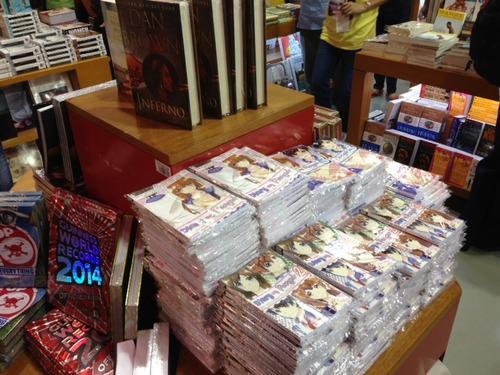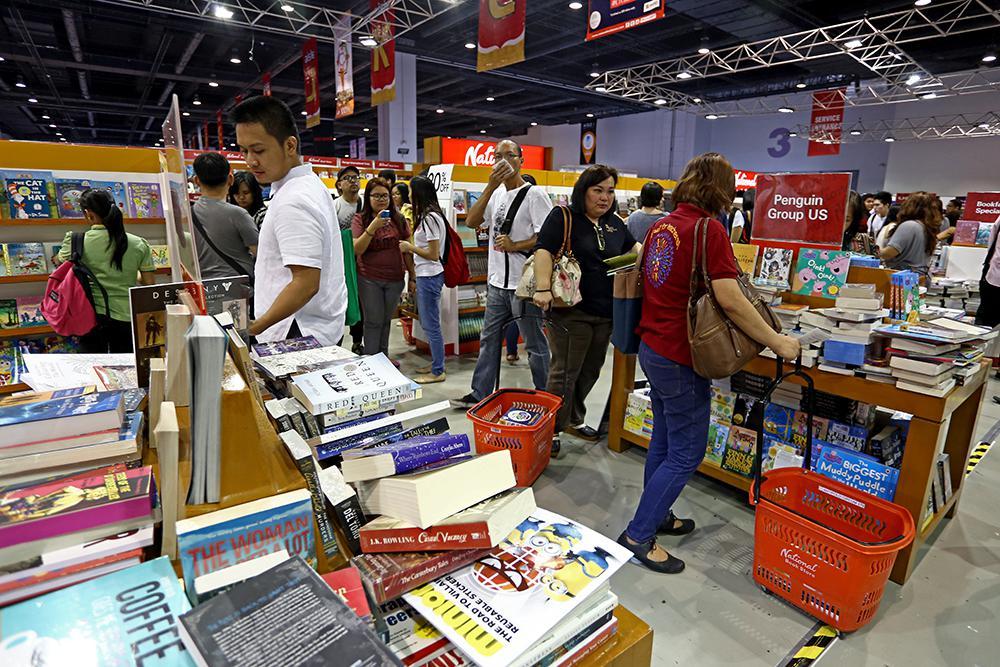The first image is the image on the left, the second image is the image on the right. Considering the images on both sides, is "Left image includes multiple media items with anime characters on the cover and a display featuring bright red and blonde wood." valid? Answer yes or no. Yes. The first image is the image on the left, the second image is the image on the right. Examine the images to the left and right. Is the description "In one of the images there are at least three people shopping in a bookstore." accurate? Answer yes or no. Yes. 